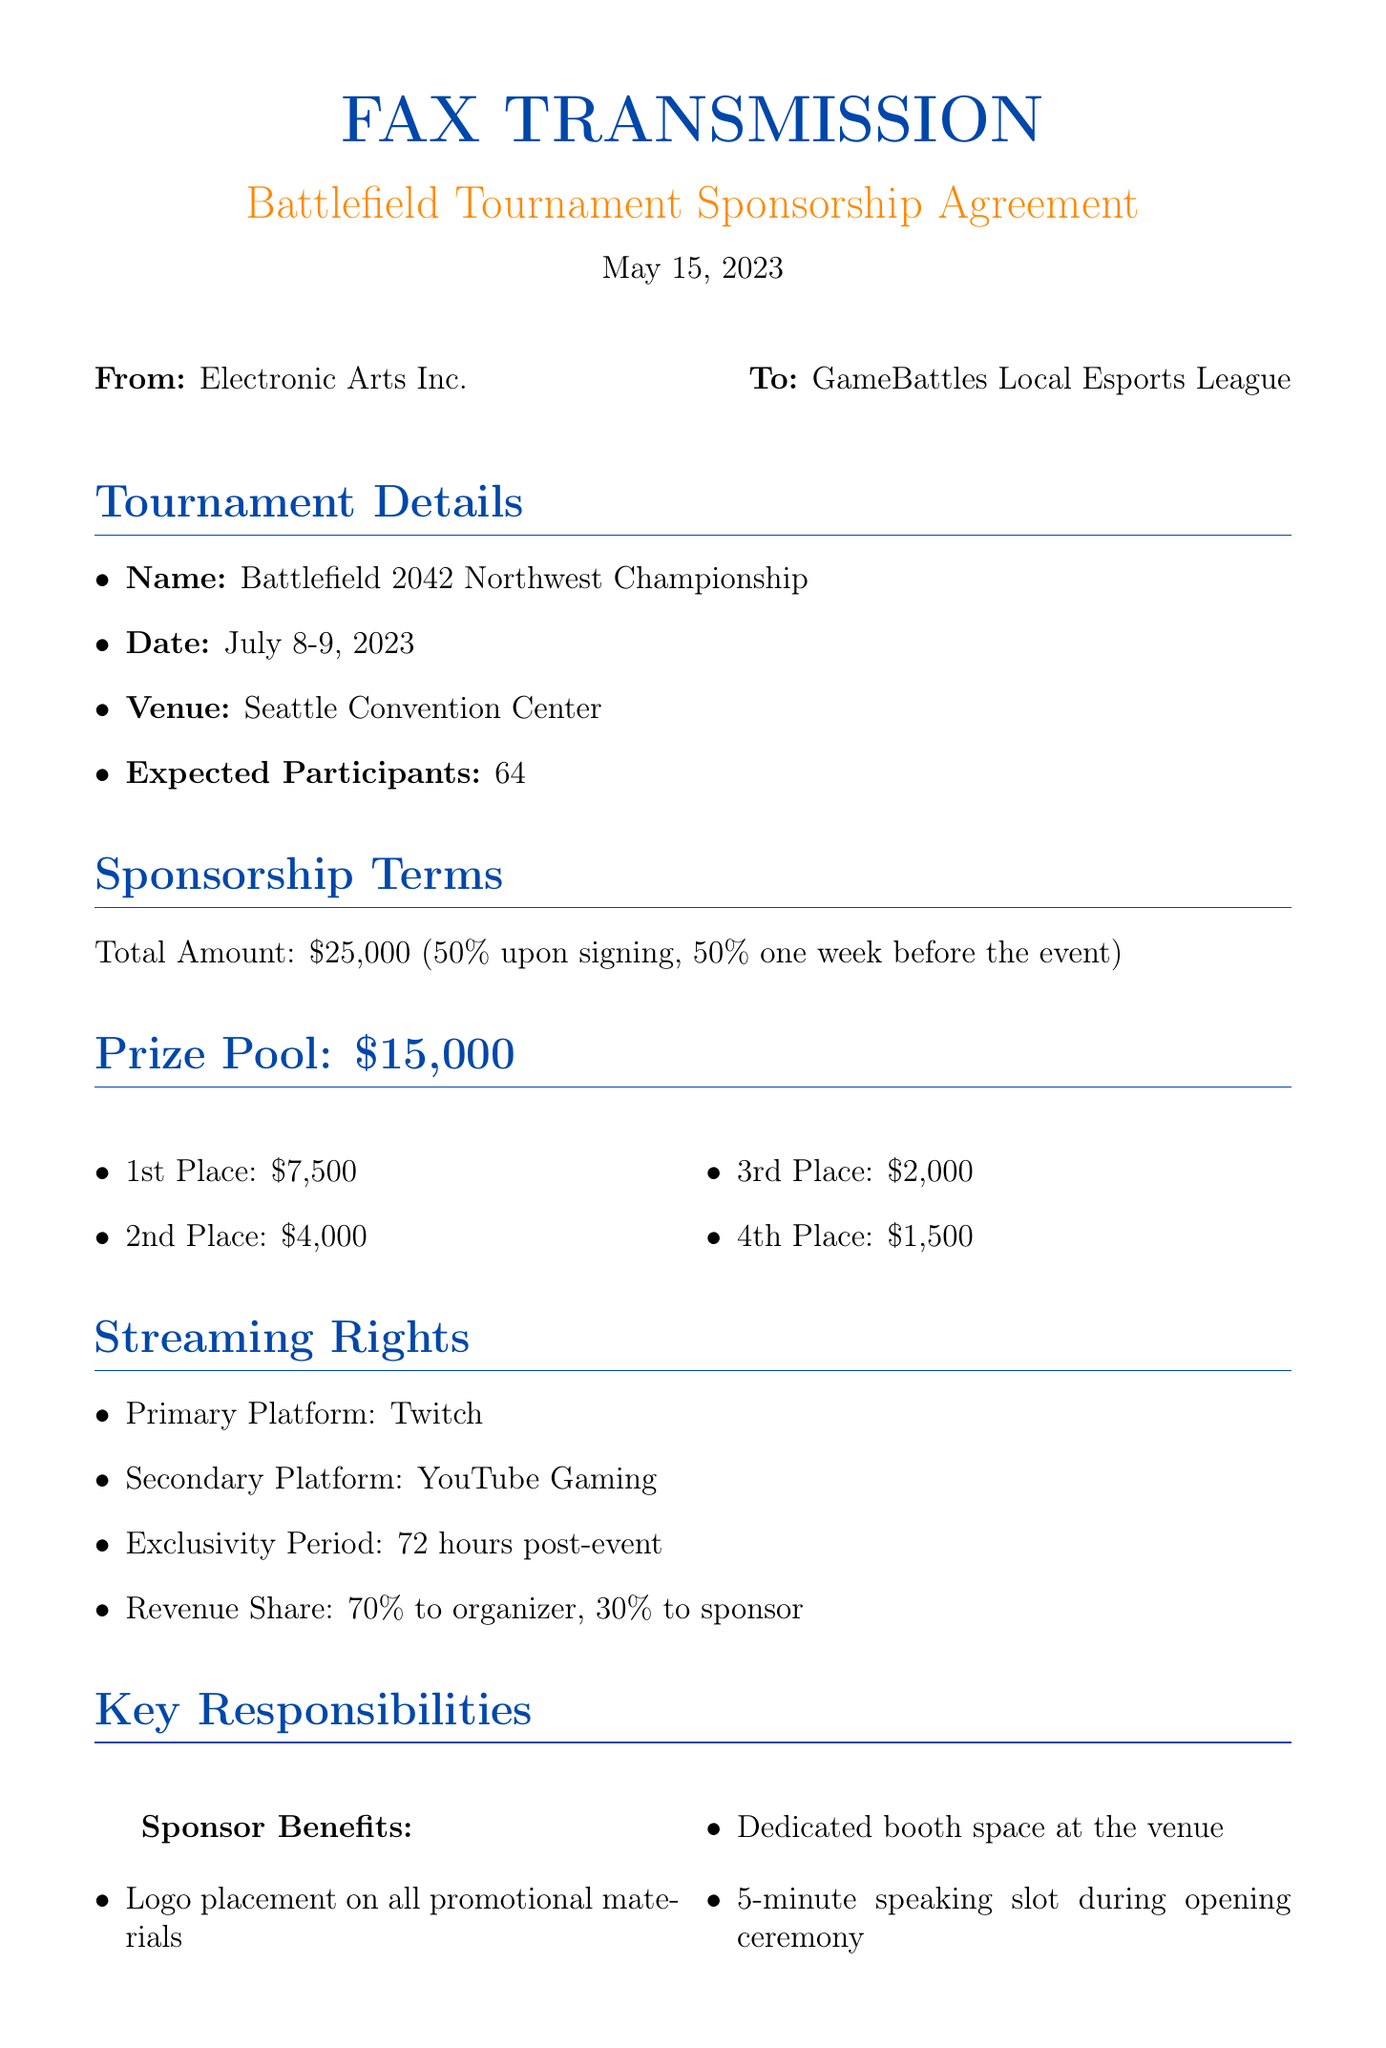What is the name of the tournament? The name of the tournament is mentioned in the document as "Battlefield 2042 Northwest Championship."
Answer: Battlefield 2042 Northwest Championship When is the tournament scheduled? The date of the tournament is provided in the document as July 8-9, 2023.
Answer: July 8-9, 2023 What is the total prize pool for the tournament? The document specifies the total prize pool as $15,000.
Answer: $15,000 How much does the first-place team receive? The first-place prize mentioned in the document is $7,500.
Answer: $7,500 What is the revenue share percentage for the sponsor? The revenue share percentage for the sponsor is stated as 30%.
Answer: 30% Who is the marketing director at EA Sports? The document mentions that John Smith is the EA Sports Marketing Director.
Answer: John Smith What is the primary streaming platform for the tournament? The primary streaming platform stated in the document is Twitch.
Answer: Twitch What venue will host the tournament? The document lists the Seattle Convention Center as the venue.
Answer: Seattle Convention Center What portion of the sponsorship amount is paid upon signing? The document indicates that 50% of the total sponsorship amount is paid upon signing.
Answer: 50% 